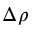<formula> <loc_0><loc_0><loc_500><loc_500>\Delta \rho</formula> 